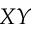<formula> <loc_0><loc_0><loc_500><loc_500>X Y</formula> 